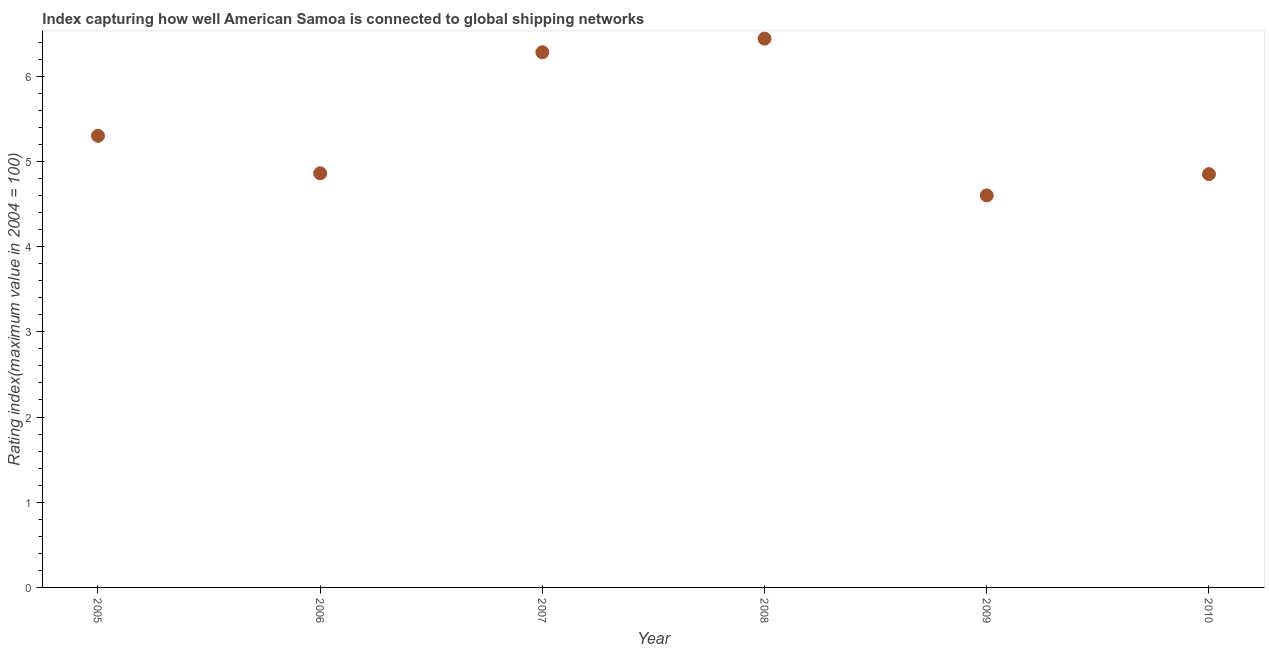What is the liner shipping connectivity index in 2010?
Provide a succinct answer. 4.85. Across all years, what is the maximum liner shipping connectivity index?
Your response must be concise. 6.44. Across all years, what is the minimum liner shipping connectivity index?
Your answer should be compact. 4.6. In which year was the liner shipping connectivity index maximum?
Your answer should be compact. 2008. In which year was the liner shipping connectivity index minimum?
Keep it short and to the point. 2009. What is the sum of the liner shipping connectivity index?
Ensure brevity in your answer.  32.33. What is the difference between the liner shipping connectivity index in 2006 and 2007?
Offer a terse response. -1.42. What is the average liner shipping connectivity index per year?
Offer a terse response. 5.39. What is the median liner shipping connectivity index?
Your answer should be compact. 5.08. In how many years, is the liner shipping connectivity index greater than 4.8 ?
Ensure brevity in your answer.  5. Do a majority of the years between 2007 and 2010 (inclusive) have liner shipping connectivity index greater than 2.2 ?
Provide a short and direct response. Yes. What is the ratio of the liner shipping connectivity index in 2006 to that in 2009?
Ensure brevity in your answer.  1.06. Is the liner shipping connectivity index in 2008 less than that in 2010?
Provide a short and direct response. No. What is the difference between the highest and the second highest liner shipping connectivity index?
Offer a terse response. 0.16. What is the difference between the highest and the lowest liner shipping connectivity index?
Provide a short and direct response. 1.84. How many dotlines are there?
Give a very brief answer. 1. How many years are there in the graph?
Provide a short and direct response. 6. Are the values on the major ticks of Y-axis written in scientific E-notation?
Ensure brevity in your answer.  No. Does the graph contain any zero values?
Offer a terse response. No. Does the graph contain grids?
Offer a terse response. No. What is the title of the graph?
Your answer should be very brief. Index capturing how well American Samoa is connected to global shipping networks. What is the label or title of the X-axis?
Your response must be concise. Year. What is the label or title of the Y-axis?
Provide a succinct answer. Rating index(maximum value in 2004 = 100). What is the Rating index(maximum value in 2004 = 100) in 2006?
Your response must be concise. 4.86. What is the Rating index(maximum value in 2004 = 100) in 2007?
Offer a very short reply. 6.28. What is the Rating index(maximum value in 2004 = 100) in 2008?
Provide a short and direct response. 6.44. What is the Rating index(maximum value in 2004 = 100) in 2010?
Offer a very short reply. 4.85. What is the difference between the Rating index(maximum value in 2004 = 100) in 2005 and 2006?
Your answer should be compact. 0.44. What is the difference between the Rating index(maximum value in 2004 = 100) in 2005 and 2007?
Your answer should be compact. -0.98. What is the difference between the Rating index(maximum value in 2004 = 100) in 2005 and 2008?
Provide a succinct answer. -1.14. What is the difference between the Rating index(maximum value in 2004 = 100) in 2005 and 2010?
Your answer should be very brief. 0.45. What is the difference between the Rating index(maximum value in 2004 = 100) in 2006 and 2007?
Ensure brevity in your answer.  -1.42. What is the difference between the Rating index(maximum value in 2004 = 100) in 2006 and 2008?
Your answer should be very brief. -1.58. What is the difference between the Rating index(maximum value in 2004 = 100) in 2006 and 2009?
Provide a succinct answer. 0.26. What is the difference between the Rating index(maximum value in 2004 = 100) in 2007 and 2008?
Offer a very short reply. -0.16. What is the difference between the Rating index(maximum value in 2004 = 100) in 2007 and 2009?
Provide a short and direct response. 1.68. What is the difference between the Rating index(maximum value in 2004 = 100) in 2007 and 2010?
Offer a terse response. 1.43. What is the difference between the Rating index(maximum value in 2004 = 100) in 2008 and 2009?
Offer a terse response. 1.84. What is the difference between the Rating index(maximum value in 2004 = 100) in 2008 and 2010?
Keep it short and to the point. 1.59. What is the difference between the Rating index(maximum value in 2004 = 100) in 2009 and 2010?
Your answer should be compact. -0.25. What is the ratio of the Rating index(maximum value in 2004 = 100) in 2005 to that in 2006?
Your answer should be very brief. 1.09. What is the ratio of the Rating index(maximum value in 2004 = 100) in 2005 to that in 2007?
Ensure brevity in your answer.  0.84. What is the ratio of the Rating index(maximum value in 2004 = 100) in 2005 to that in 2008?
Your answer should be very brief. 0.82. What is the ratio of the Rating index(maximum value in 2004 = 100) in 2005 to that in 2009?
Your response must be concise. 1.15. What is the ratio of the Rating index(maximum value in 2004 = 100) in 2005 to that in 2010?
Provide a short and direct response. 1.09. What is the ratio of the Rating index(maximum value in 2004 = 100) in 2006 to that in 2007?
Keep it short and to the point. 0.77. What is the ratio of the Rating index(maximum value in 2004 = 100) in 2006 to that in 2008?
Provide a succinct answer. 0.76. What is the ratio of the Rating index(maximum value in 2004 = 100) in 2006 to that in 2009?
Offer a terse response. 1.06. What is the ratio of the Rating index(maximum value in 2004 = 100) in 2007 to that in 2008?
Give a very brief answer. 0.97. What is the ratio of the Rating index(maximum value in 2004 = 100) in 2007 to that in 2009?
Offer a very short reply. 1.36. What is the ratio of the Rating index(maximum value in 2004 = 100) in 2007 to that in 2010?
Keep it short and to the point. 1.29. What is the ratio of the Rating index(maximum value in 2004 = 100) in 2008 to that in 2009?
Make the answer very short. 1.4. What is the ratio of the Rating index(maximum value in 2004 = 100) in 2008 to that in 2010?
Your answer should be very brief. 1.33. What is the ratio of the Rating index(maximum value in 2004 = 100) in 2009 to that in 2010?
Offer a terse response. 0.95. 